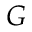Convert formula to latex. <formula><loc_0><loc_0><loc_500><loc_500>G</formula> 